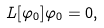Convert formula to latex. <formula><loc_0><loc_0><loc_500><loc_500>L [ \varphi _ { 0 } ] \varphi _ { 0 } = 0 ,</formula> 